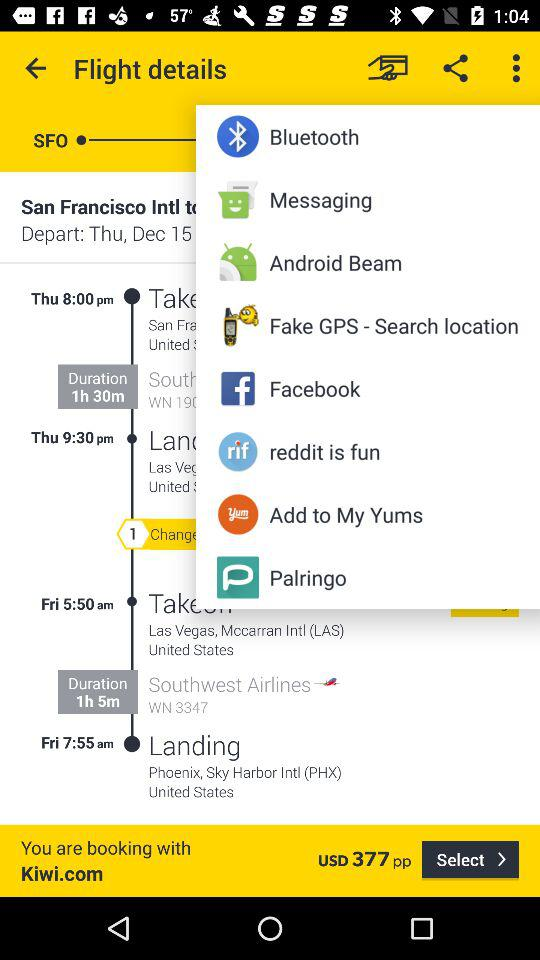Through what app can the booking be done? The booking can be done through "Kiwi.com". 